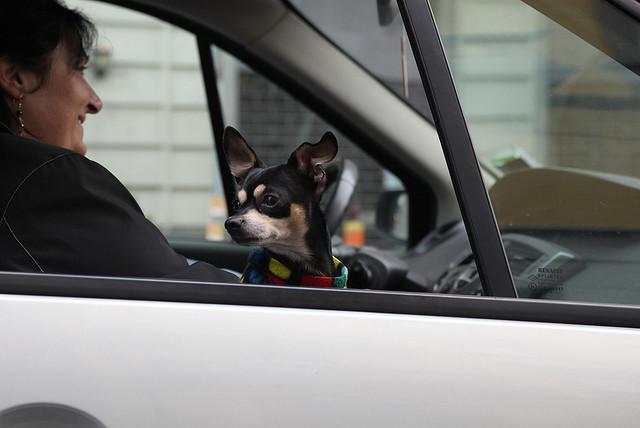What is this dog's owner doing?
Choose the right answer from the provided options to respond to the question.
Options: Driving, shaving, drinking, sewing. Driving. 